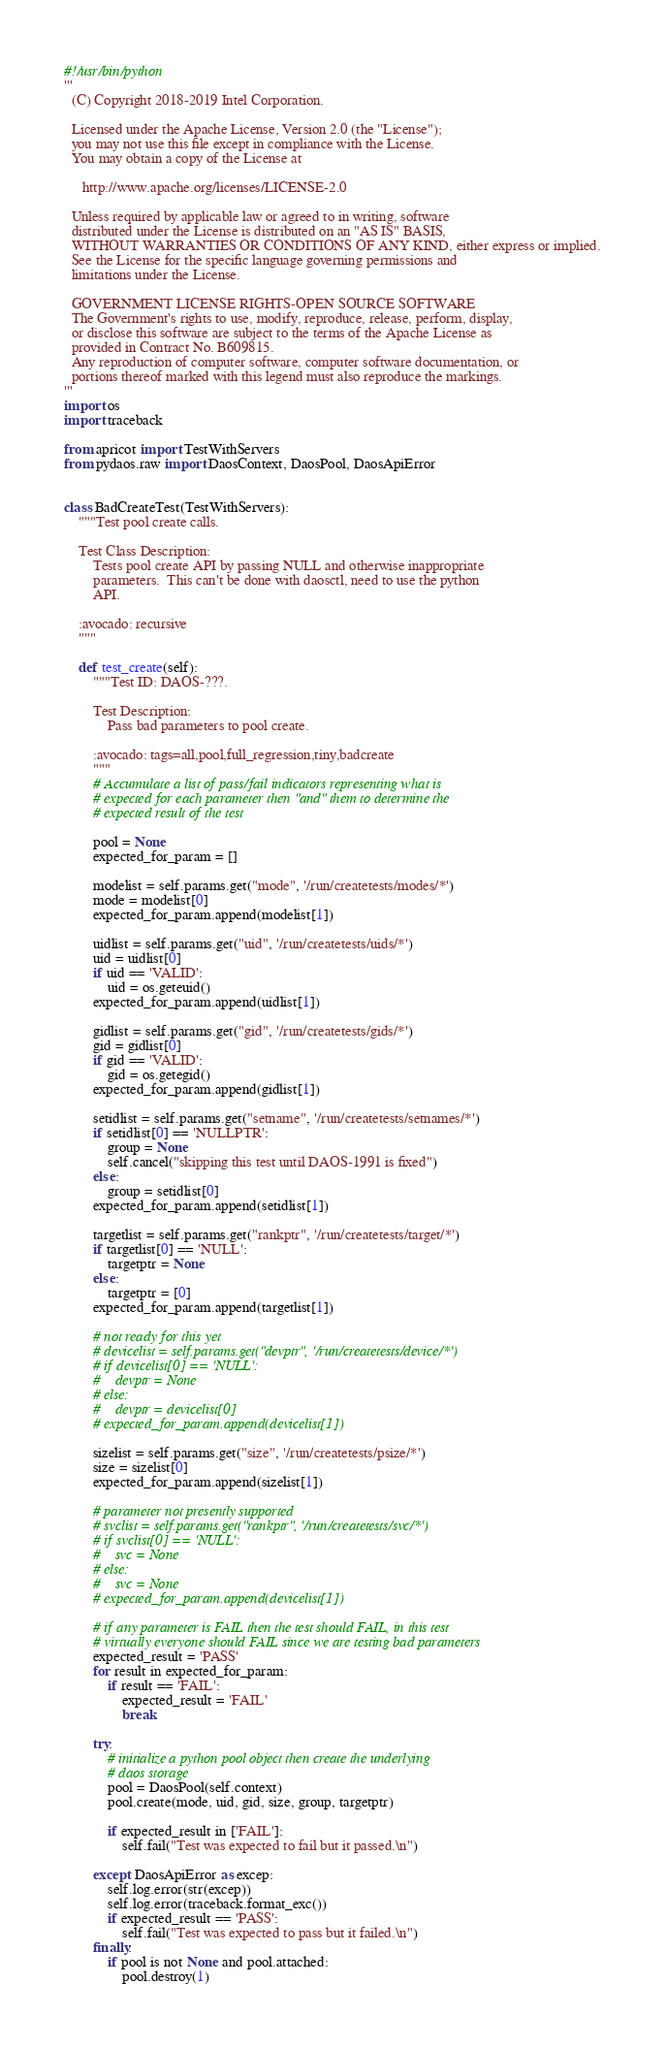Convert code to text. <code><loc_0><loc_0><loc_500><loc_500><_Python_>#!/usr/bin/python
'''
  (C) Copyright 2018-2019 Intel Corporation.

  Licensed under the Apache License, Version 2.0 (the "License");
  you may not use this file except in compliance with the License.
  You may obtain a copy of the License at

     http://www.apache.org/licenses/LICENSE-2.0

  Unless required by applicable law or agreed to in writing, software
  distributed under the License is distributed on an "AS IS" BASIS,
  WITHOUT WARRANTIES OR CONDITIONS OF ANY KIND, either express or implied.
  See the License for the specific language governing permissions and
  limitations under the License.

  GOVERNMENT LICENSE RIGHTS-OPEN SOURCE SOFTWARE
  The Government's rights to use, modify, reproduce, release, perform, display,
  or disclose this software are subject to the terms of the Apache License as
  provided in Contract No. B609815.
  Any reproduction of computer software, computer software documentation, or
  portions thereof marked with this legend must also reproduce the markings.
'''
import os
import traceback

from apricot import TestWithServers
from pydaos.raw import DaosContext, DaosPool, DaosApiError


class BadCreateTest(TestWithServers):
    """Test pool create calls.

    Test Class Description:
        Tests pool create API by passing NULL and otherwise inappropriate
        parameters.  This can't be done with daosctl, need to use the python
        API.

    :avocado: recursive
    """

    def test_create(self):
        """Test ID: DAOS-???.

        Test Description:
            Pass bad parameters to pool create.

        :avocado: tags=all,pool,full_regression,tiny,badcreate
        """
        # Accumulate a list of pass/fail indicators representing what is
        # expected for each parameter then "and" them to determine the
        # expected result of the test

        pool = None
        expected_for_param = []

        modelist = self.params.get("mode", '/run/createtests/modes/*')
        mode = modelist[0]
        expected_for_param.append(modelist[1])

        uidlist = self.params.get("uid", '/run/createtests/uids/*')
        uid = uidlist[0]
        if uid == 'VALID':
            uid = os.geteuid()
        expected_for_param.append(uidlist[1])

        gidlist = self.params.get("gid", '/run/createtests/gids/*')
        gid = gidlist[0]
        if gid == 'VALID':
            gid = os.getegid()
        expected_for_param.append(gidlist[1])

        setidlist = self.params.get("setname", '/run/createtests/setnames/*')
        if setidlist[0] == 'NULLPTR':
            group = None
            self.cancel("skipping this test until DAOS-1991 is fixed")
        else:
            group = setidlist[0]
        expected_for_param.append(setidlist[1])

        targetlist = self.params.get("rankptr", '/run/createtests/target/*')
        if targetlist[0] == 'NULL':
            targetptr = None
        else:
            targetptr = [0]
        expected_for_param.append(targetlist[1])

        # not ready for this yet
        # devicelist = self.params.get("devptr", '/run/createtests/device/*')
        # if devicelist[0] == 'NULL':
        #    devptr = None
        # else:
        #    devptr = devicelist[0]
        # expected_for_param.append(devicelist[1])

        sizelist = self.params.get("size", '/run/createtests/psize/*')
        size = sizelist[0]
        expected_for_param.append(sizelist[1])

        # parameter not presently supported
        # svclist = self.params.get("rankptr", '/run/createtests/svc/*')
        # if svclist[0] == 'NULL':
        #    svc = None
        # else:
        #    svc = None
        # expected_for_param.append(devicelist[1])

        # if any parameter is FAIL then the test should FAIL, in this test
        # virtually everyone should FAIL since we are testing bad parameters
        expected_result = 'PASS'
        for result in expected_for_param:
            if result == 'FAIL':
                expected_result = 'FAIL'
                break

        try:
            # initialize a python pool object then create the underlying
            # daos storage
            pool = DaosPool(self.context)
            pool.create(mode, uid, gid, size, group, targetptr)

            if expected_result in ['FAIL']:
                self.fail("Test was expected to fail but it passed.\n")

        except DaosApiError as excep:
            self.log.error(str(excep))
            self.log.error(traceback.format_exc())
            if expected_result == 'PASS':
                self.fail("Test was expected to pass but it failed.\n")
        finally:
            if pool is not None and pool.attached:
                pool.destroy(1)
</code> 